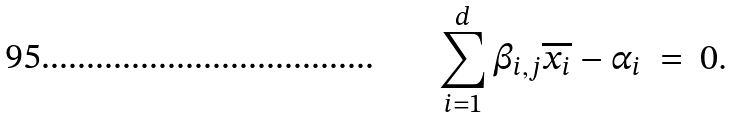Convert formula to latex. <formula><loc_0><loc_0><loc_500><loc_500>\sum _ { i = 1 } ^ { d } \beta _ { i , j } \overline { x _ { i } } - \alpha _ { i } \ = \ 0 .</formula> 